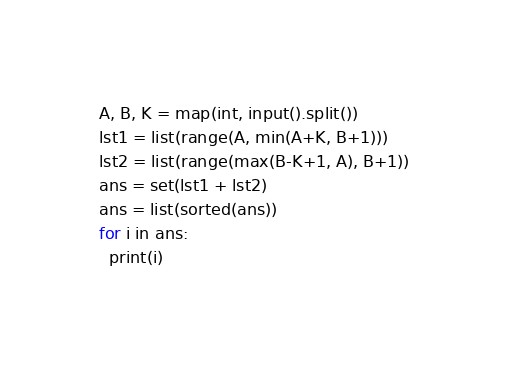<code> <loc_0><loc_0><loc_500><loc_500><_Python_>A, B, K = map(int, input().split())
lst1 = list(range(A, min(A+K, B+1)))
lst2 = list(range(max(B-K+1, A), B+1))
ans = set(lst1 + lst2)
ans = list(sorted(ans))
for i in ans:
  print(i)</code> 